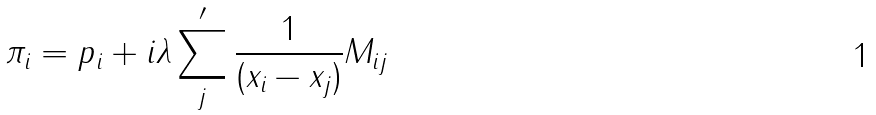Convert formula to latex. <formula><loc_0><loc_0><loc_500><loc_500>\pi _ { i } = p _ { i } + i \lambda \sum _ { j } ^ { \prime } { \frac { 1 } { ( x _ { i } - x _ { j } ) } } M _ { i j }</formula> 